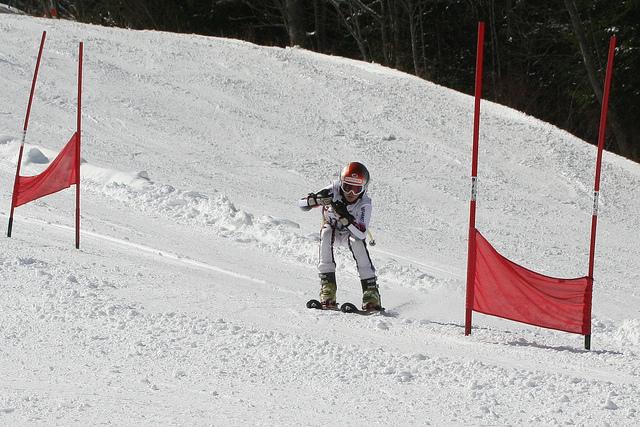IS this a competition or free ski?
Quick response, please. Competition. What color are the flags?
Answer briefly. Red. What covers the ground?
Short answer required. Snow. 